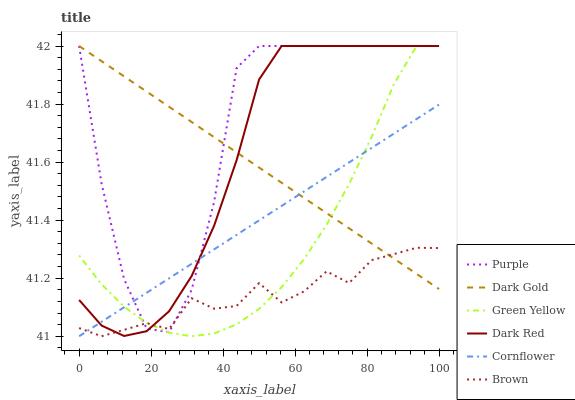Does Brown have the minimum area under the curve?
Answer yes or no. Yes. Does Purple have the maximum area under the curve?
Answer yes or no. Yes. Does Purple have the minimum area under the curve?
Answer yes or no. No. Does Brown have the maximum area under the curve?
Answer yes or no. No. Is Dark Gold the smoothest?
Answer yes or no. Yes. Is Purple the roughest?
Answer yes or no. Yes. Is Brown the smoothest?
Answer yes or no. No. Is Brown the roughest?
Answer yes or no. No. Does Cornflower have the lowest value?
Answer yes or no. Yes. Does Purple have the lowest value?
Answer yes or no. No. Does Green Yellow have the highest value?
Answer yes or no. Yes. Does Brown have the highest value?
Answer yes or no. No. Does Green Yellow intersect Brown?
Answer yes or no. Yes. Is Green Yellow less than Brown?
Answer yes or no. No. Is Green Yellow greater than Brown?
Answer yes or no. No. 